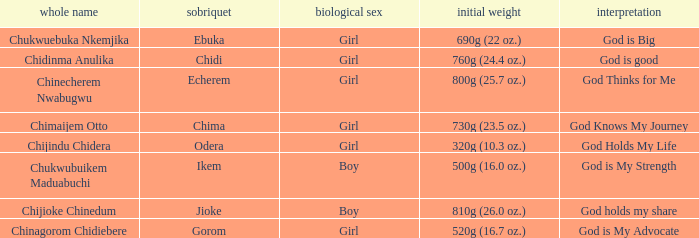What is the nickname of the baby with the birth weight of 730g (23.5 oz.)? Chima. 